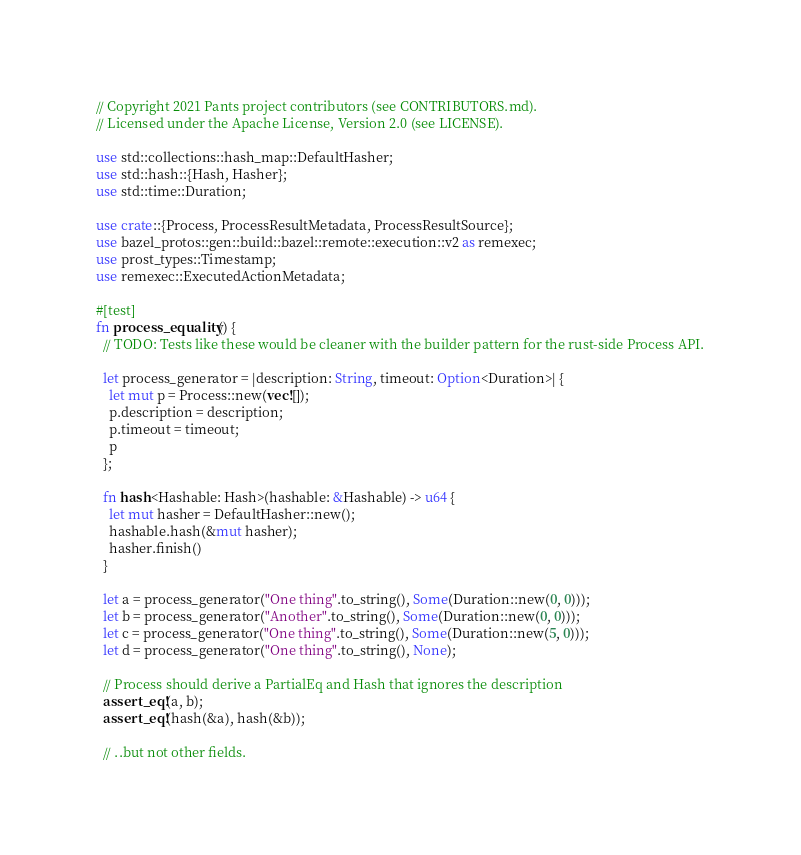Convert code to text. <code><loc_0><loc_0><loc_500><loc_500><_Rust_>// Copyright 2021 Pants project contributors (see CONTRIBUTORS.md).
// Licensed under the Apache License, Version 2.0 (see LICENSE).

use std::collections::hash_map::DefaultHasher;
use std::hash::{Hash, Hasher};
use std::time::Duration;

use crate::{Process, ProcessResultMetadata, ProcessResultSource};
use bazel_protos::gen::build::bazel::remote::execution::v2 as remexec;
use prost_types::Timestamp;
use remexec::ExecutedActionMetadata;

#[test]
fn process_equality() {
  // TODO: Tests like these would be cleaner with the builder pattern for the rust-side Process API.

  let process_generator = |description: String, timeout: Option<Duration>| {
    let mut p = Process::new(vec![]);
    p.description = description;
    p.timeout = timeout;
    p
  };

  fn hash<Hashable: Hash>(hashable: &Hashable) -> u64 {
    let mut hasher = DefaultHasher::new();
    hashable.hash(&mut hasher);
    hasher.finish()
  }

  let a = process_generator("One thing".to_string(), Some(Duration::new(0, 0)));
  let b = process_generator("Another".to_string(), Some(Duration::new(0, 0)));
  let c = process_generator("One thing".to_string(), Some(Duration::new(5, 0)));
  let d = process_generator("One thing".to_string(), None);

  // Process should derive a PartialEq and Hash that ignores the description
  assert_eq!(a, b);
  assert_eq!(hash(&a), hash(&b));

  // ..but not other fields.</code> 